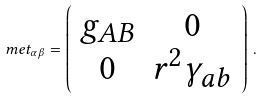<formula> <loc_0><loc_0><loc_500><loc_500>\ m e t _ { \alpha \beta } = \left ( \begin{array} { c c } g _ { A B } & 0 \\ 0 & r ^ { 2 } \gamma _ { a b } \end{array} \right ) \, .</formula> 